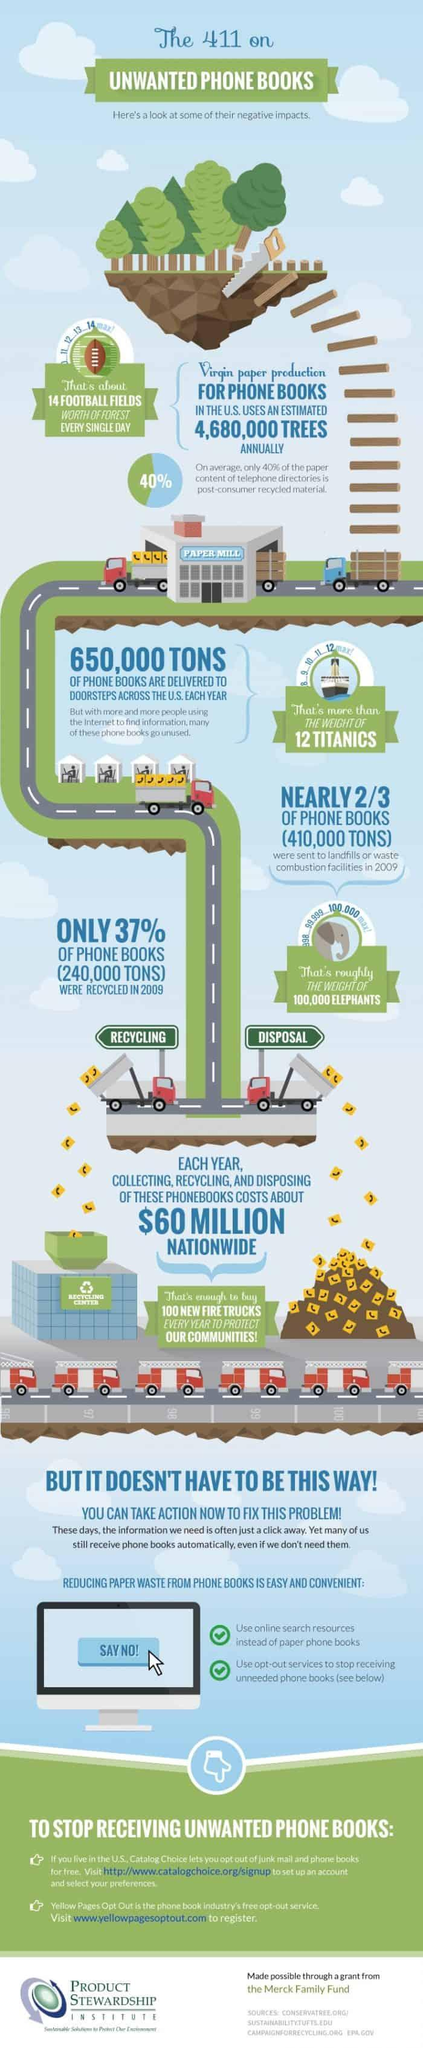Mention a couple of crucial points in this snapshot. In 2009, approximately 100,000 elephants' worth of phone books were sent to landfills, based on the comparison made by experts. According to recent studies, only 40% of the paper used in telephone directories is made from recycled materials. Each year, the weight of phone books delivered across the US is compared to the weight of 12 Titanic ships. 